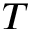<formula> <loc_0><loc_0><loc_500><loc_500>T</formula> 